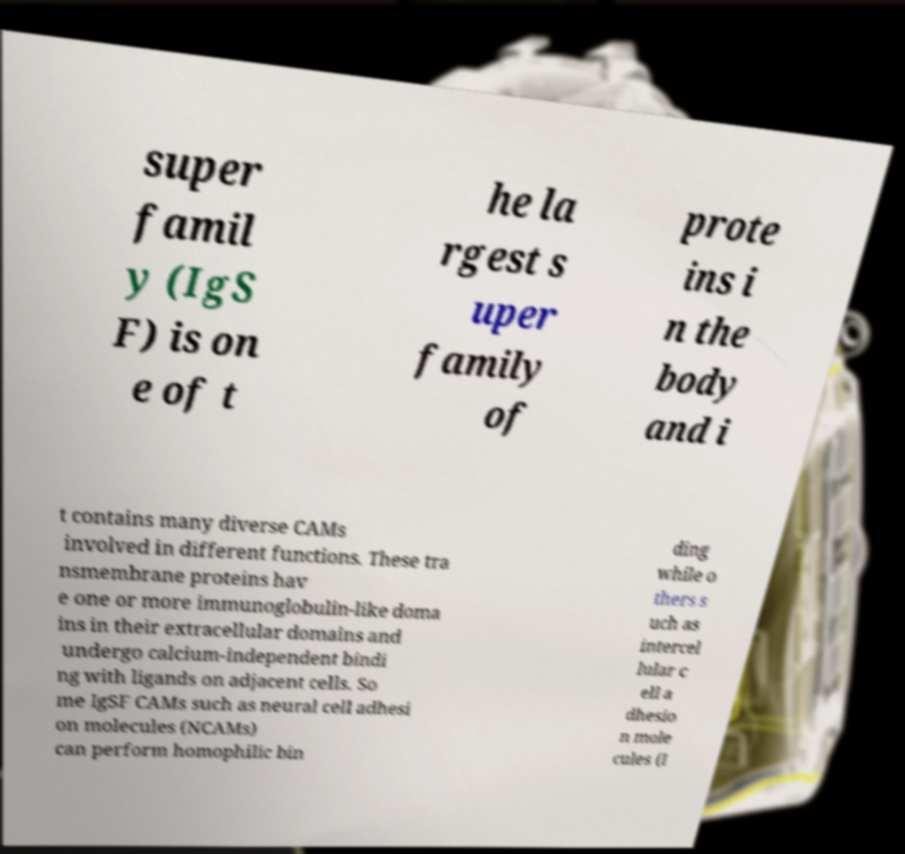There's text embedded in this image that I need extracted. Can you transcribe it verbatim? super famil y (IgS F) is on e of t he la rgest s uper family of prote ins i n the body and i t contains many diverse CAMs involved in different functions. These tra nsmembrane proteins hav e one or more immunoglobulin-like doma ins in their extracellular domains and undergo calcium-independent bindi ng with ligands on adjacent cells. So me IgSF CAMs such as neural cell adhesi on molecules (NCAMs) can perform homophilic bin ding while o thers s uch as intercel lular c ell a dhesio n mole cules (I 